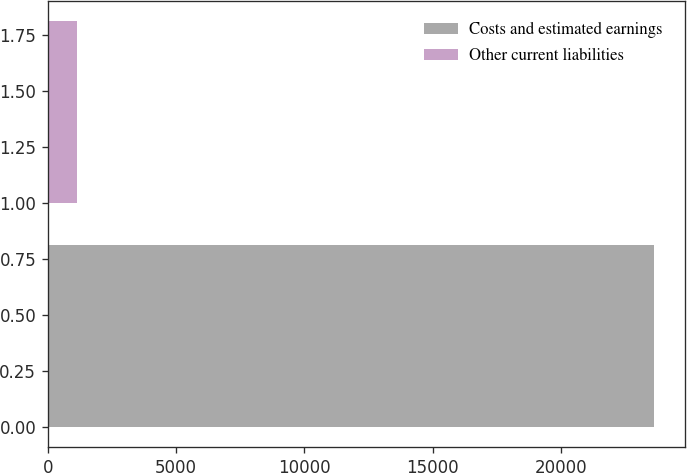<chart> <loc_0><loc_0><loc_500><loc_500><bar_chart><fcel>Costs and estimated earnings<fcel>Other current liabilities<nl><fcel>23644<fcel>1120<nl></chart> 